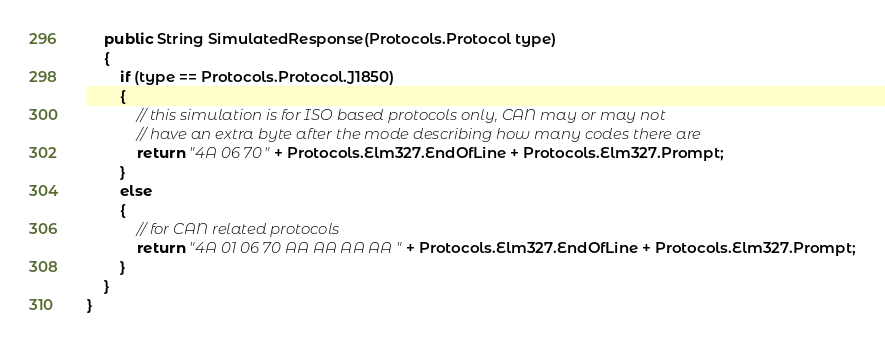<code> <loc_0><loc_0><loc_500><loc_500><_Java_>    public String SimulatedResponse(Protocols.Protocol type)
    {
        if (type == Protocols.Protocol.J1850)
        {
            // this simulation is for ISO based protocols only, CAN may or may not
            // have an extra byte after the mode describing how many codes there are
            return "4A 06 70" + Protocols.Elm327.EndOfLine + Protocols.Elm327.Prompt;
        }
        else
        {
            // for CAN related protocols
            return "4A 01 06 70 AA AA AA AA" + Protocols.Elm327.EndOfLine + Protocols.Elm327.Prompt;
        }
    }
}
</code> 